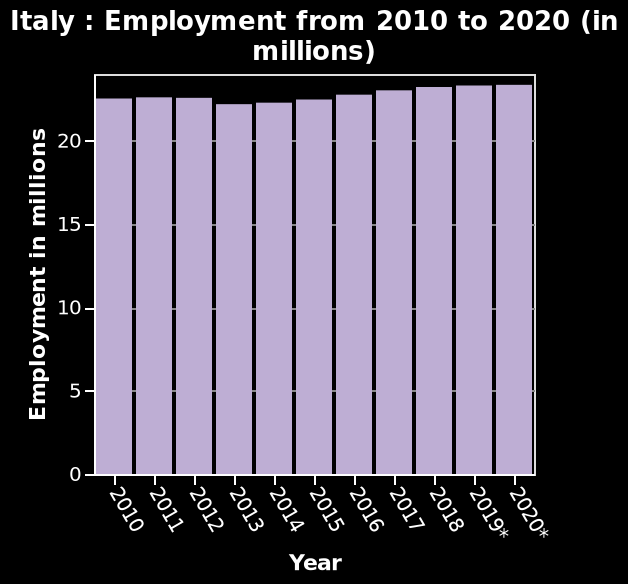<image>
What does the x-axis represent on the bar graph?  The x-axis on the bar graph represents the years from 2010 to 2020. 